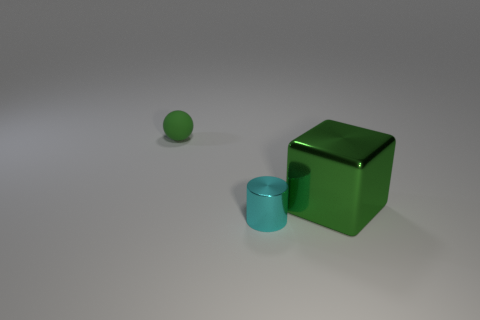Is there any other thing that has the same size as the green shiny cube?
Make the answer very short. No. Do the rubber sphere and the shiny block have the same color?
Offer a very short reply. Yes. There is a cyan cylinder that is the same size as the sphere; what is it made of?
Your answer should be very brief. Metal. Are the green cube and the small cyan thing made of the same material?
Keep it short and to the point. Yes. What number of small cylinders are made of the same material as the large block?
Offer a very short reply. 1. How many things are either things that are on the right side of the ball or metallic objects that are to the right of the tiny shiny cylinder?
Your answer should be compact. 2. Are there more cyan metal cylinders in front of the tiny matte ball than big green metallic cubes that are in front of the tiny cyan metal object?
Give a very brief answer. Yes. What is the color of the small thing behind the large green block?
Provide a succinct answer. Green. Are there any other objects that have the same shape as the green metallic object?
Give a very brief answer. No. How many blue things are rubber spheres or metallic objects?
Provide a short and direct response. 0. 